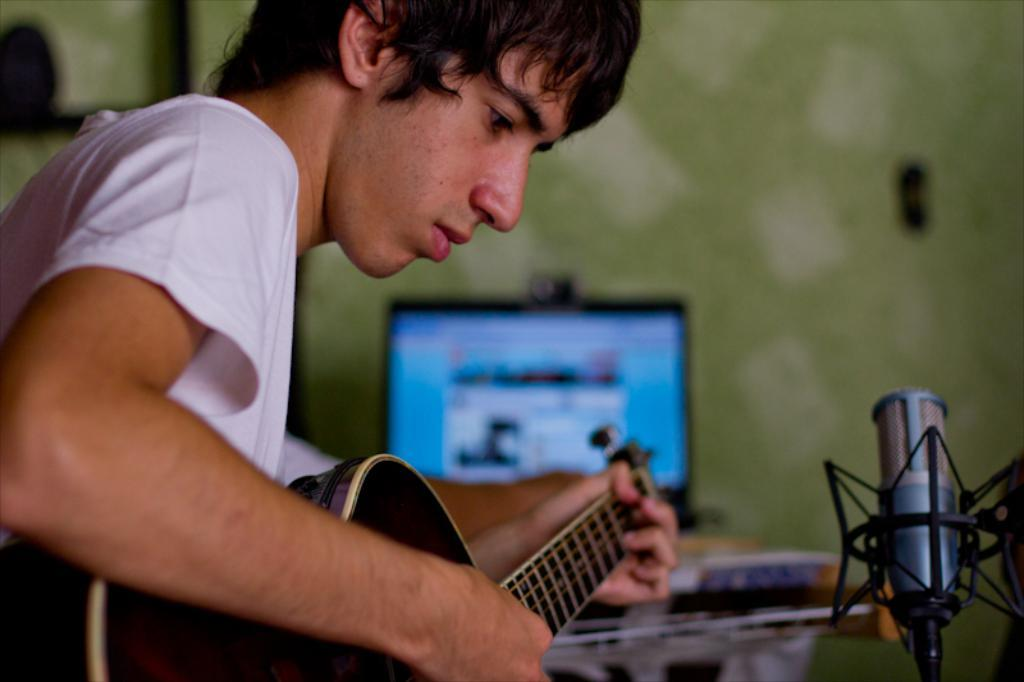Who is the person in the image? There is a man in the image. What is the man wearing? The man is wearing a white t-shirt. What is the man doing in the image? The man is playing a guitar. What objects can be seen on the table in the image? There is a monitor on a table in the image. What device is used for amplifying the man's voice in the image? There is a microphone (mic) in the image. Can you see the man's friend skating in the image? There is no friend or skating activity present in the image. What type of mist is covering the man's guitar in the image? There is no mist present in the image; the guitar is clearly visible. 